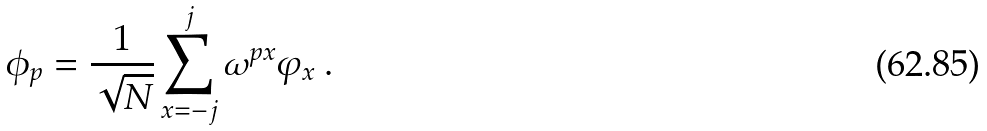Convert formula to latex. <formula><loc_0><loc_0><loc_500><loc_500>\phi _ { p } = \frac { 1 } { \sqrt { N } } \sum _ { x = - j } ^ { j } \omega ^ { p x } \varphi _ { x } \ .</formula> 